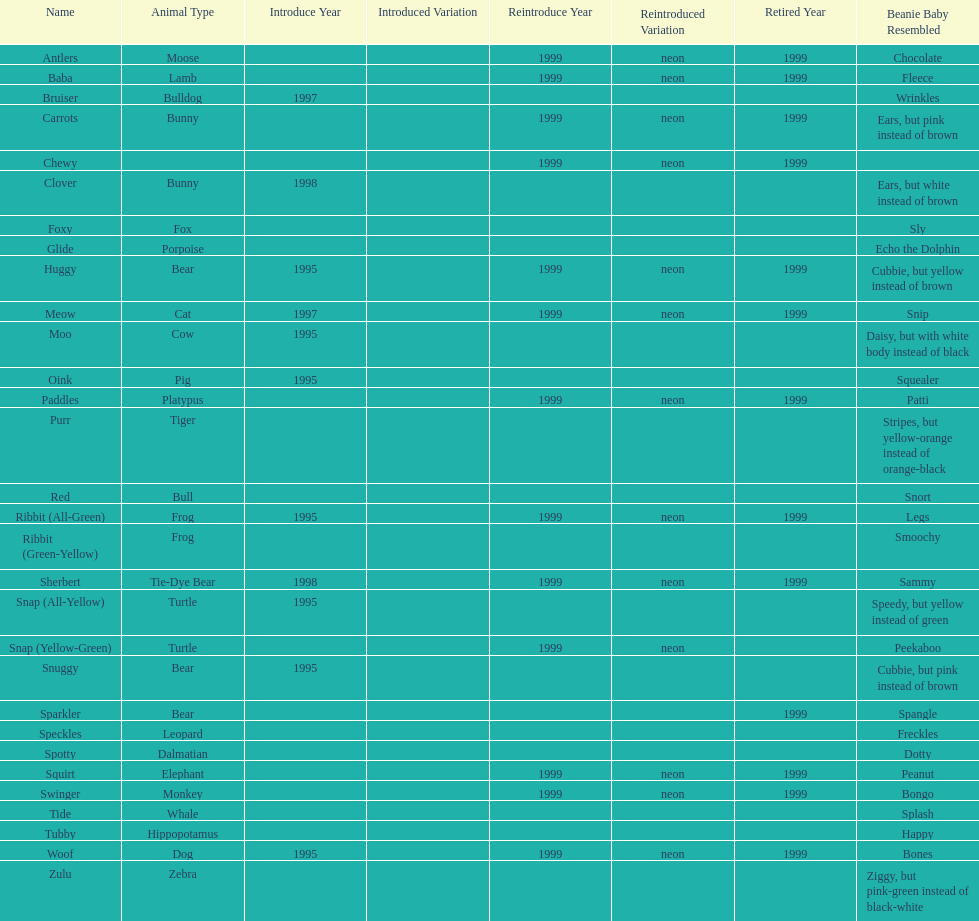What is the name of the pillow pal listed after clover? Foxy. 